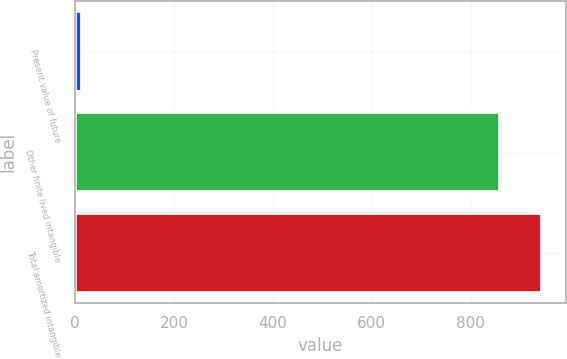Convert chart. <chart><loc_0><loc_0><loc_500><loc_500><bar_chart><fcel>Present value of future<fcel>Other finite lived intangible<fcel>Total amortized intangible<nl><fcel>13.5<fcel>858.8<fcel>944.68<nl></chart> 